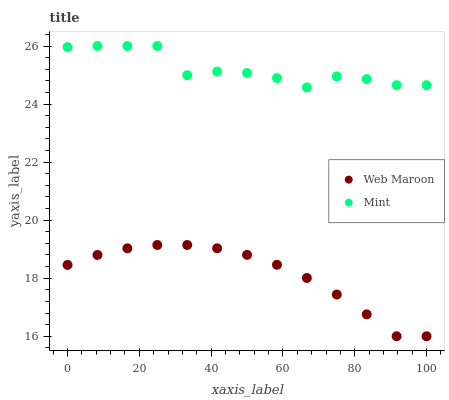Does Web Maroon have the minimum area under the curve?
Answer yes or no. Yes. Does Mint have the maximum area under the curve?
Answer yes or no. Yes. Does Web Maroon have the maximum area under the curve?
Answer yes or no. No. Is Web Maroon the smoothest?
Answer yes or no. Yes. Is Mint the roughest?
Answer yes or no. Yes. Is Web Maroon the roughest?
Answer yes or no. No. Does Web Maroon have the lowest value?
Answer yes or no. Yes. Does Mint have the highest value?
Answer yes or no. Yes. Does Web Maroon have the highest value?
Answer yes or no. No. Is Web Maroon less than Mint?
Answer yes or no. Yes. Is Mint greater than Web Maroon?
Answer yes or no. Yes. Does Web Maroon intersect Mint?
Answer yes or no. No. 